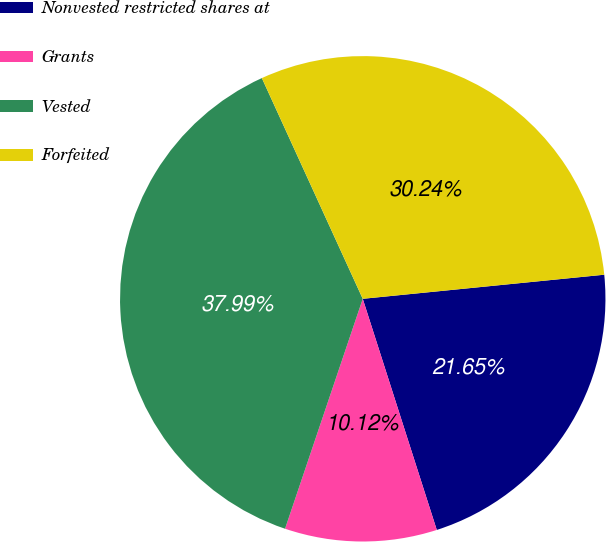Convert chart to OTSL. <chart><loc_0><loc_0><loc_500><loc_500><pie_chart><fcel>Nonvested restricted shares at<fcel>Grants<fcel>Vested<fcel>Forfeited<nl><fcel>21.65%<fcel>10.12%<fcel>37.99%<fcel>30.24%<nl></chart> 